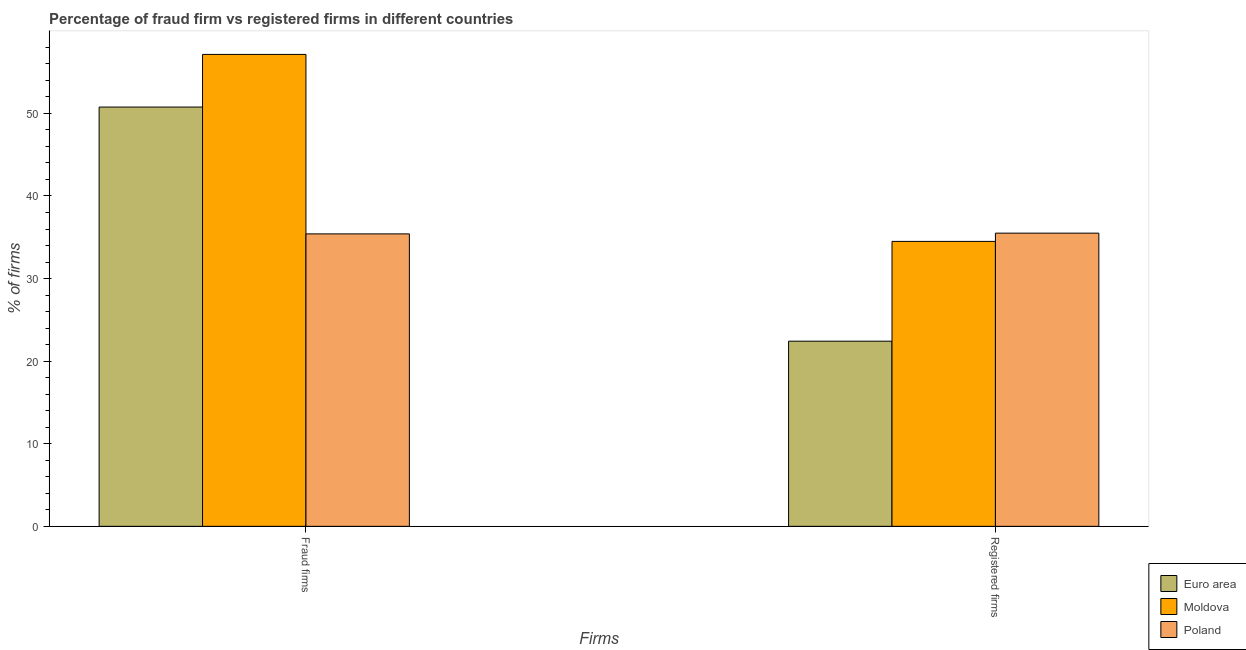How many groups of bars are there?
Your answer should be compact. 2. Are the number of bars per tick equal to the number of legend labels?
Provide a succinct answer. Yes. What is the label of the 1st group of bars from the left?
Keep it short and to the point. Fraud firms. What is the percentage of fraud firms in Euro area?
Your answer should be compact. 50.77. Across all countries, what is the maximum percentage of fraud firms?
Offer a very short reply. 57.14. Across all countries, what is the minimum percentage of fraud firms?
Offer a very short reply. 35.41. In which country was the percentage of registered firms maximum?
Give a very brief answer. Poland. What is the total percentage of registered firms in the graph?
Your answer should be very brief. 92.42. What is the difference between the percentage of fraud firms in Euro area and that in Poland?
Offer a terse response. 15.36. What is the difference between the percentage of fraud firms in Euro area and the percentage of registered firms in Moldova?
Provide a succinct answer. 16.27. What is the average percentage of fraud firms per country?
Ensure brevity in your answer.  47.77. What is the difference between the percentage of fraud firms and percentage of registered firms in Euro area?
Give a very brief answer. 28.35. What is the ratio of the percentage of fraud firms in Moldova to that in Poland?
Offer a terse response. 1.61. What does the 1st bar from the left in Fraud firms represents?
Offer a terse response. Euro area. What does the 2nd bar from the right in Fraud firms represents?
Your response must be concise. Moldova. Are the values on the major ticks of Y-axis written in scientific E-notation?
Keep it short and to the point. No. Does the graph contain grids?
Your answer should be compact. No. Where does the legend appear in the graph?
Give a very brief answer. Bottom right. How are the legend labels stacked?
Your response must be concise. Vertical. What is the title of the graph?
Offer a very short reply. Percentage of fraud firm vs registered firms in different countries. Does "Barbados" appear as one of the legend labels in the graph?
Your response must be concise. No. What is the label or title of the X-axis?
Offer a terse response. Firms. What is the label or title of the Y-axis?
Your answer should be compact. % of firms. What is the % of firms in Euro area in Fraud firms?
Offer a terse response. 50.77. What is the % of firms in Moldova in Fraud firms?
Your answer should be very brief. 57.14. What is the % of firms of Poland in Fraud firms?
Ensure brevity in your answer.  35.41. What is the % of firms in Euro area in Registered firms?
Offer a terse response. 22.42. What is the % of firms in Moldova in Registered firms?
Ensure brevity in your answer.  34.5. What is the % of firms of Poland in Registered firms?
Offer a terse response. 35.5. Across all Firms, what is the maximum % of firms in Euro area?
Keep it short and to the point. 50.77. Across all Firms, what is the maximum % of firms in Moldova?
Give a very brief answer. 57.14. Across all Firms, what is the maximum % of firms of Poland?
Your answer should be compact. 35.5. Across all Firms, what is the minimum % of firms of Euro area?
Provide a succinct answer. 22.42. Across all Firms, what is the minimum % of firms of Moldova?
Provide a succinct answer. 34.5. Across all Firms, what is the minimum % of firms of Poland?
Provide a short and direct response. 35.41. What is the total % of firms in Euro area in the graph?
Provide a succinct answer. 73.19. What is the total % of firms in Moldova in the graph?
Provide a short and direct response. 91.64. What is the total % of firms of Poland in the graph?
Your answer should be compact. 70.91. What is the difference between the % of firms in Euro area in Fraud firms and that in Registered firms?
Your response must be concise. 28.35. What is the difference between the % of firms in Moldova in Fraud firms and that in Registered firms?
Your response must be concise. 22.64. What is the difference between the % of firms in Poland in Fraud firms and that in Registered firms?
Provide a short and direct response. -0.09. What is the difference between the % of firms in Euro area in Fraud firms and the % of firms in Moldova in Registered firms?
Your answer should be very brief. 16.27. What is the difference between the % of firms in Euro area in Fraud firms and the % of firms in Poland in Registered firms?
Give a very brief answer. 15.27. What is the difference between the % of firms of Moldova in Fraud firms and the % of firms of Poland in Registered firms?
Your answer should be compact. 21.64. What is the average % of firms of Euro area per Firms?
Offer a terse response. 36.59. What is the average % of firms in Moldova per Firms?
Ensure brevity in your answer.  45.82. What is the average % of firms of Poland per Firms?
Provide a short and direct response. 35.45. What is the difference between the % of firms in Euro area and % of firms in Moldova in Fraud firms?
Your response must be concise. -6.37. What is the difference between the % of firms in Euro area and % of firms in Poland in Fraud firms?
Provide a succinct answer. 15.36. What is the difference between the % of firms in Moldova and % of firms in Poland in Fraud firms?
Keep it short and to the point. 21.73. What is the difference between the % of firms in Euro area and % of firms in Moldova in Registered firms?
Keep it short and to the point. -12.08. What is the difference between the % of firms in Euro area and % of firms in Poland in Registered firms?
Offer a terse response. -13.08. What is the ratio of the % of firms in Euro area in Fraud firms to that in Registered firms?
Your answer should be very brief. 2.26. What is the ratio of the % of firms in Moldova in Fraud firms to that in Registered firms?
Your answer should be compact. 1.66. What is the ratio of the % of firms of Poland in Fraud firms to that in Registered firms?
Provide a succinct answer. 1. What is the difference between the highest and the second highest % of firms in Euro area?
Your answer should be compact. 28.35. What is the difference between the highest and the second highest % of firms of Moldova?
Offer a terse response. 22.64. What is the difference between the highest and the second highest % of firms of Poland?
Offer a very short reply. 0.09. What is the difference between the highest and the lowest % of firms in Euro area?
Your answer should be compact. 28.35. What is the difference between the highest and the lowest % of firms in Moldova?
Provide a short and direct response. 22.64. What is the difference between the highest and the lowest % of firms in Poland?
Keep it short and to the point. 0.09. 